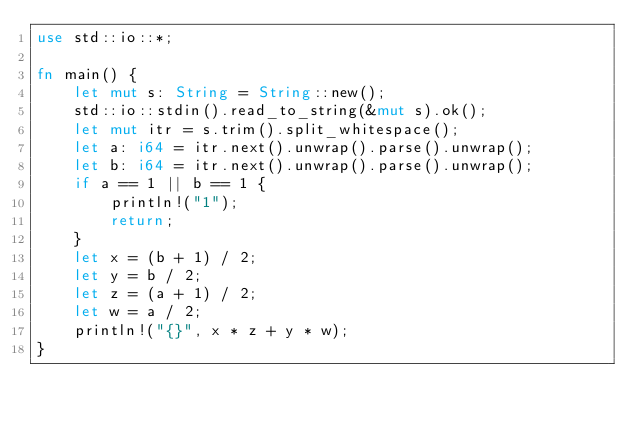Convert code to text. <code><loc_0><loc_0><loc_500><loc_500><_Rust_>use std::io::*;

fn main() {
    let mut s: String = String::new();
    std::io::stdin().read_to_string(&mut s).ok();
    let mut itr = s.trim().split_whitespace();
    let a: i64 = itr.next().unwrap().parse().unwrap();
    let b: i64 = itr.next().unwrap().parse().unwrap();
    if a == 1 || b == 1 {
        println!("1");
        return;
    }
    let x = (b + 1) / 2;
    let y = b / 2;
    let z = (a + 1) / 2;
    let w = a / 2;
    println!("{}", x * z + y * w);
}
</code> 